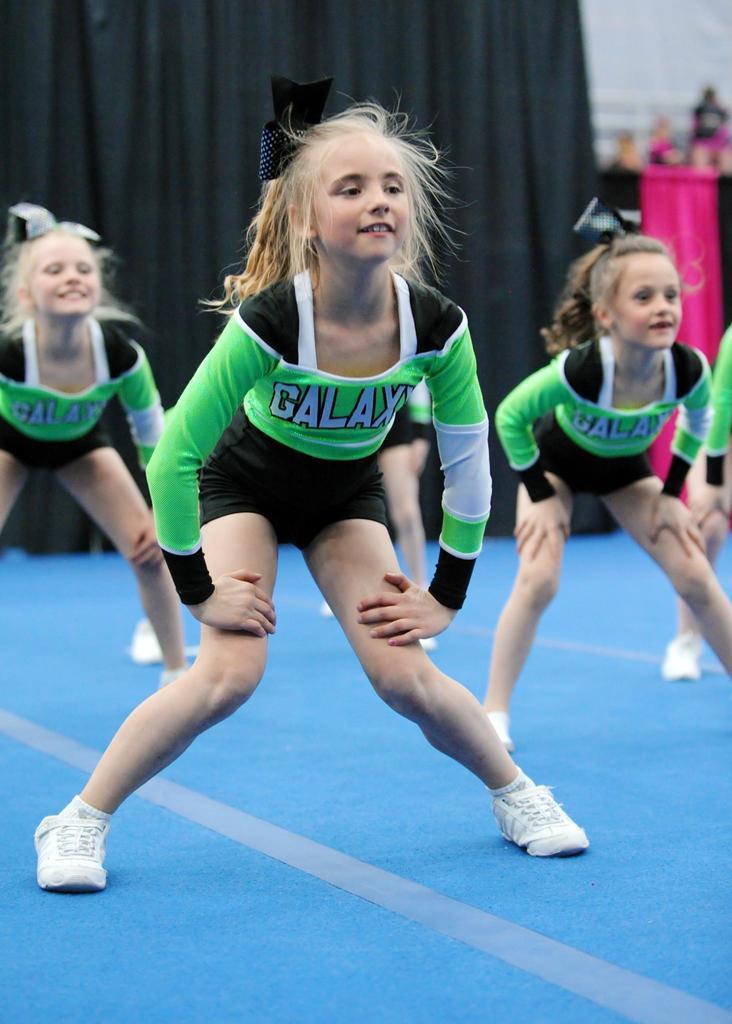What team do these girls cheer for?
Your answer should be very brief. Galaxy. How many galaxy tsirts are there in this picture?
Offer a very short reply. 3. 